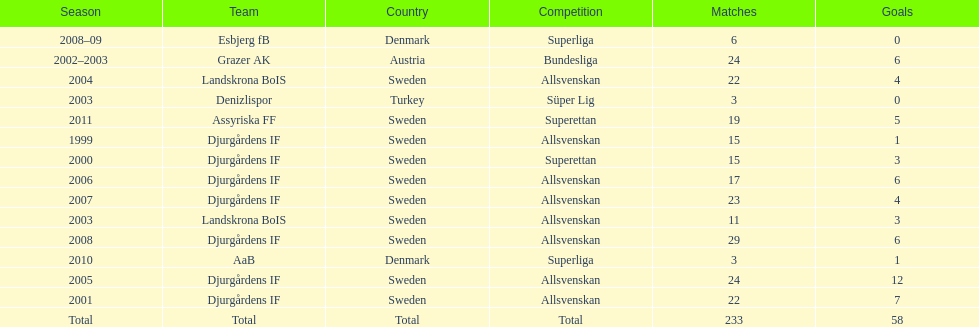What team has the most goals? Djurgårdens IF. 